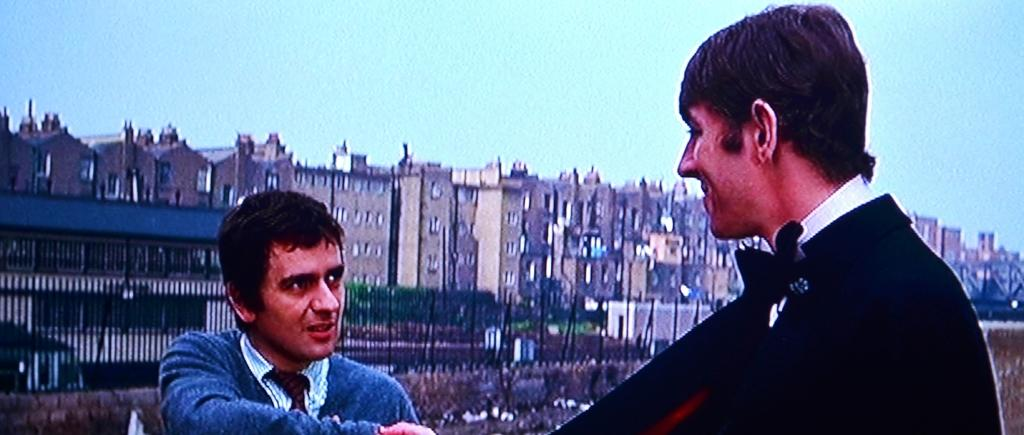How many people are in the image? There are two persons in the image. What are the two persons doing in the image? The two persons are talking to each other. What can be seen in the background of the image? There are buildings, trees, and the sky visible in the background of the image. What type of stew is being served for breakfast in the image? There is no stew or breakfast depicted in the image; it features two people talking to each other with a background of buildings, trees, and the sky. 